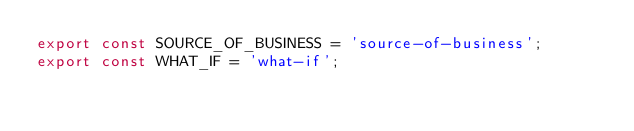<code> <loc_0><loc_0><loc_500><loc_500><_JavaScript_>export const SOURCE_OF_BUSINESS = 'source-of-business';
export const WHAT_IF = 'what-if';
</code> 